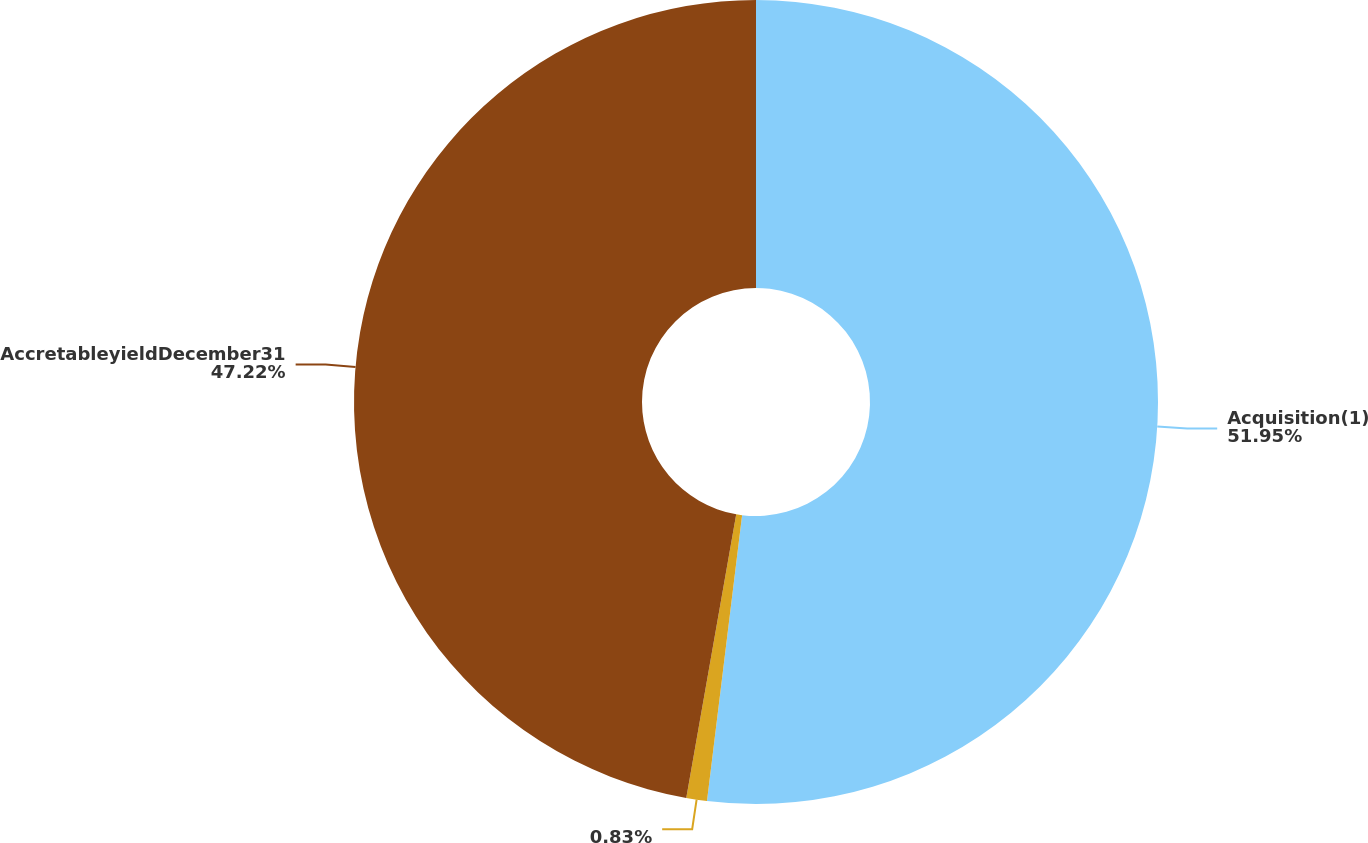Convert chart. <chart><loc_0><loc_0><loc_500><loc_500><pie_chart><fcel>Acquisition(1)<fcel>Unnamed: 1<fcel>AccretableyieldDecember31<nl><fcel>51.94%<fcel>0.83%<fcel>47.22%<nl></chart> 